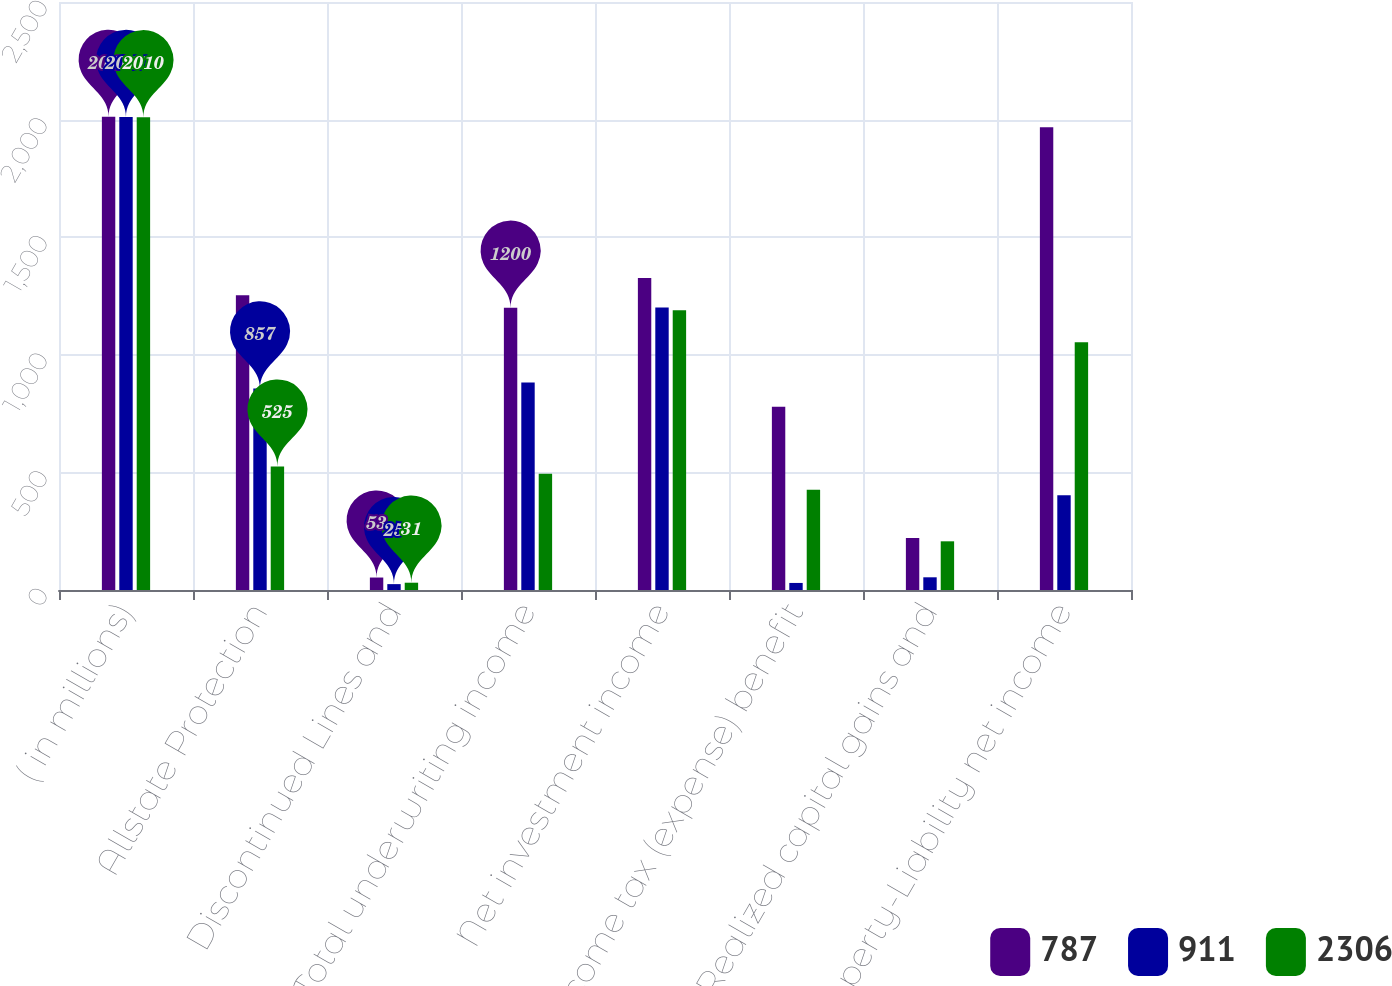Convert chart to OTSL. <chart><loc_0><loc_0><loc_500><loc_500><stacked_bar_chart><ecel><fcel>( in millions)<fcel>Allstate Protection<fcel>Discontinued Lines and<fcel>Total underwriting income<fcel>Net investment income<fcel>Income tax (expense) benefit<fcel>Realized capital gains and<fcel>Property-Liability net income<nl><fcel>787<fcel>2012<fcel>1253<fcel>53<fcel>1200<fcel>1326<fcel>779<fcel>221<fcel>1968<nl><fcel>911<fcel>2011<fcel>857<fcel>25<fcel>882<fcel>1201<fcel>30<fcel>54<fcel>403<nl><fcel>2306<fcel>2010<fcel>525<fcel>31<fcel>494<fcel>1189<fcel>426<fcel>207<fcel>1053<nl></chart> 